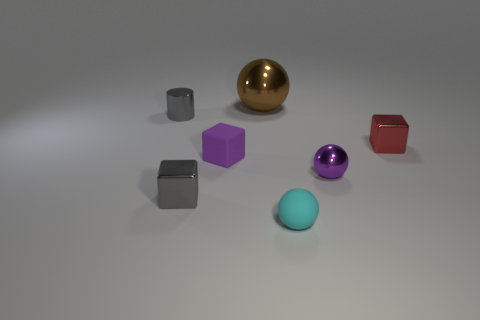Add 1 purple blocks. How many objects exist? 8 Subtract all spheres. How many objects are left? 4 Add 5 shiny cylinders. How many shiny cylinders are left? 6 Add 4 big cyan blocks. How many big cyan blocks exist? 4 Subtract 0 yellow balls. How many objects are left? 7 Subtract all large brown metallic cylinders. Subtract all tiny shiny cubes. How many objects are left? 5 